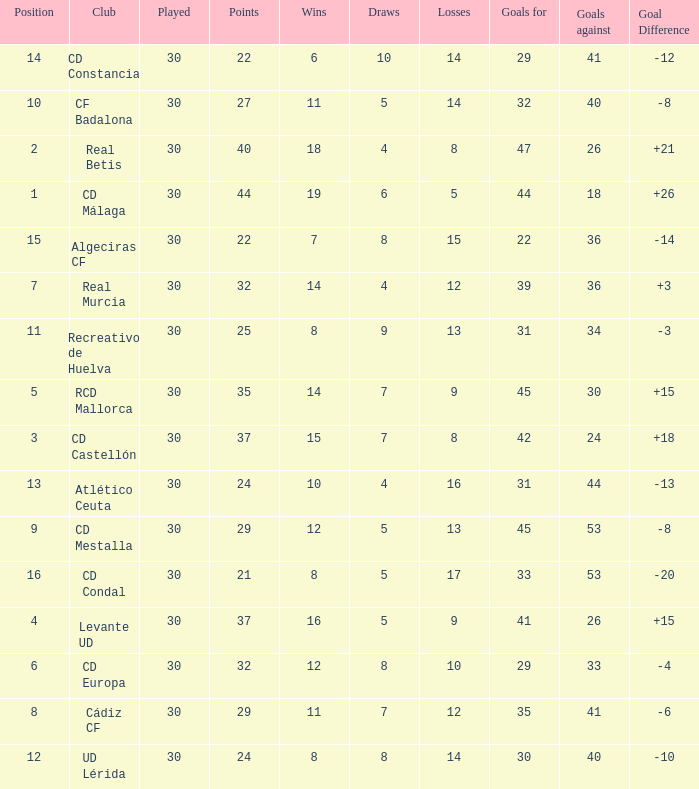What is the goals for when played is larger than 30? None. 